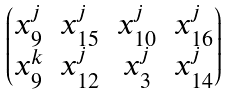Convert formula to latex. <formula><loc_0><loc_0><loc_500><loc_500>\begin{pmatrix} x _ { 9 } ^ { j } & x _ { 1 5 } ^ { j } & x _ { 1 0 } ^ { j } & x _ { 1 6 } ^ { j } \\ x _ { 9 } ^ { k } & x _ { 1 2 } ^ { j } & x _ { 3 } ^ { j } & x _ { 1 4 } ^ { j } \end{pmatrix}</formula> 